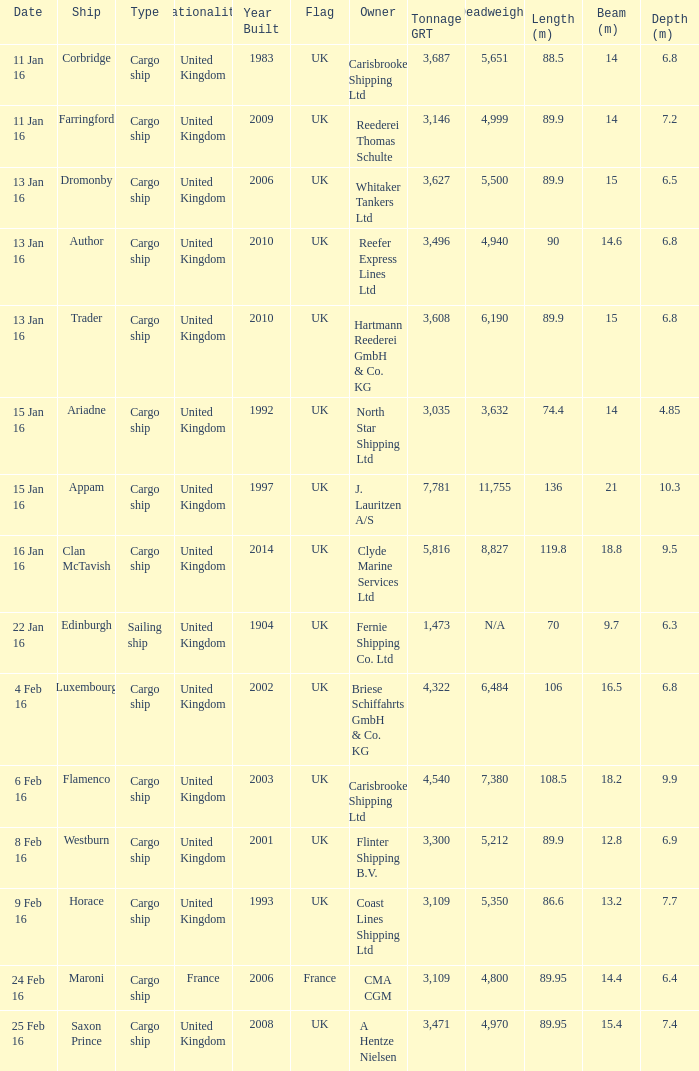What is the total tonnage grt of the cargo ship(s) sunk or captured on 4 feb 16? 1.0. Write the full table. {'header': ['Date', 'Ship', 'Type', 'Nationality', 'Year Built', 'Flag', 'Owner', 'Tonnage GRT', 'Deadweight', 'Length (m)', 'Beam (m)', 'Depth (m)'], 'rows': [['11 Jan 16', 'Corbridge', 'Cargo ship', 'United Kingdom', '1983', 'UK', 'Carisbrooke Shipping Ltd', '3,687', '5,651', '88.5', '14', '6.8'], ['11 Jan 16', 'Farringford', 'Cargo ship', 'United Kingdom', '2009', 'UK', 'Reederei Thomas Schulte', '3,146', '4,999', '89.9', '14', '7.2'], ['13 Jan 16', 'Dromonby', 'Cargo ship', 'United Kingdom', '2006', 'UK', 'Whitaker Tankers Ltd', '3,627', '5,500', '89.9', '15', '6.5'], ['13 Jan 16', 'Author', 'Cargo ship', 'United Kingdom', '2010', 'UK', 'Reefer Express Lines Ltd', '3,496', '4,940', '90', '14.6', '6.8'], ['13 Jan 16', 'Trader', 'Cargo ship', 'United Kingdom', '2010', 'UK', 'Hartmann Reederei GmbH & Co. KG', '3,608', '6,190', '89.9', '15', '6.8'], ['15 Jan 16', 'Ariadne', 'Cargo ship', 'United Kingdom', '1992', 'UK', 'North Star Shipping Ltd', '3,035', '3,632', '74.4', '14', '4.85'], ['15 Jan 16', 'Appam', 'Cargo ship', 'United Kingdom', '1997', 'UK', 'J. Lauritzen A/S', '7,781', '11,755', '136', '21', '10.3'], ['16 Jan 16', 'Clan McTavish', 'Cargo ship', 'United Kingdom', '2014', 'UK', 'Clyde Marine Services Ltd', '5,816', '8,827', '119.8', '18.8', '9.5'], ['22 Jan 16', 'Edinburgh', 'Sailing ship', 'United Kingdom', '1904', 'UK', 'Fernie Shipping Co. Ltd', '1,473', 'N/A', '70', '9.7', '6.3'], ['4 Feb 16', 'Luxembourg', 'Cargo ship', 'United Kingdom', '2002', 'UK', 'Briese Schiffahrts GmbH & Co. KG', '4,322', '6,484', '106', '16.5', '6.8'], ['6 Feb 16', 'Flamenco', 'Cargo ship', 'United Kingdom', '2003', 'UK', 'Carisbrooke Shipping Ltd', '4,540', '7,380', '108.5', '18.2', '9.9'], ['8 Feb 16', 'Westburn', 'Cargo ship', 'United Kingdom', '2001', 'UK', 'Flinter Shipping B.V.', '3,300', '5,212', '89.9', '12.8', '6.9'], ['9 Feb 16', 'Horace', 'Cargo ship', 'United Kingdom', '1993', 'UK', 'Coast Lines Shipping Ltd', '3,109', '5,350', '86.6', '13.2', '7.7'], ['24 Feb 16', 'Maroni', 'Cargo ship', 'France', '2006', 'France', 'CMA CGM', '3,109', '4,800', '89.95', '14.4', '6.4'], ['25 Feb 16', 'Saxon Prince', 'Cargo ship', 'United Kingdom', '2008', 'UK', 'A Hentze Nielsen', '3,471', '4,970', '89.95', '15.4', '7.4']]} 